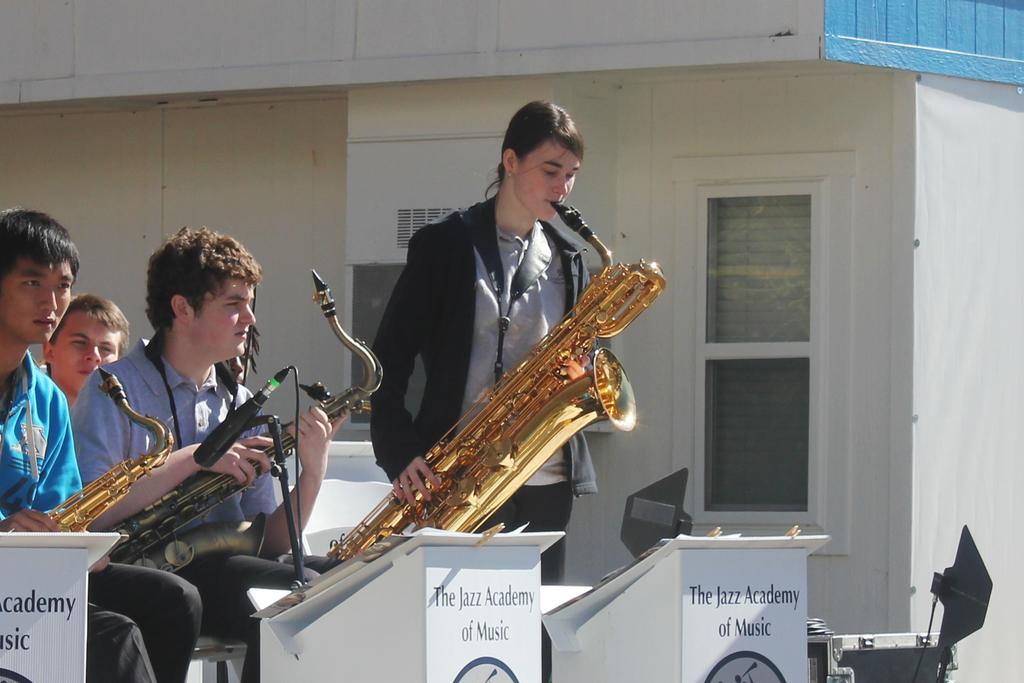Provide a one-sentence caption for the provided image. The Jazz Academy of Music features several young talented saxophone players. 